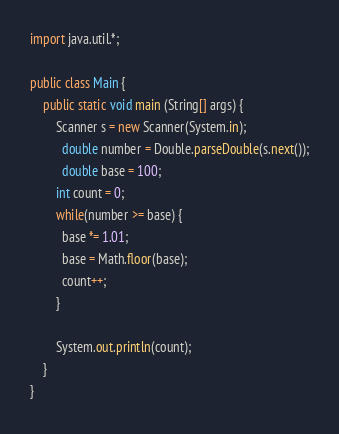Convert code to text. <code><loc_0><loc_0><loc_500><loc_500><_Java_>import java.util.*;

public class Main {
    public static void main (String[] args) {
        Scanner s = new Scanner(System.in);
          double number = Double.parseDouble(s.next());
          double base = 100;
      	int count = 0;
      	while(number >= base) {
          base *= 1.01;
          base = Math.floor(base);
          count++;
        }
      	
      	System.out.println(count);
    }
} 
</code> 